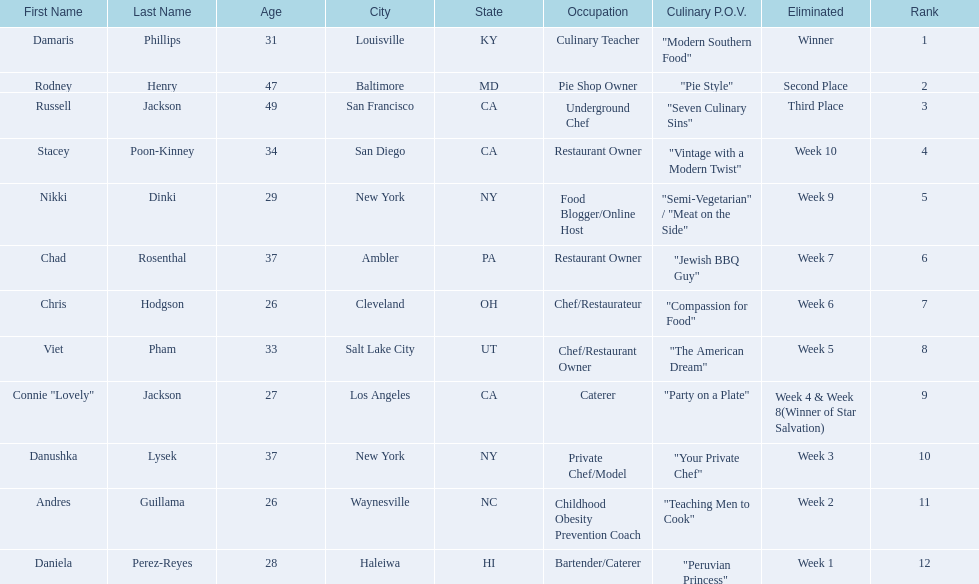How many competitors were under the age of 30? 5. 